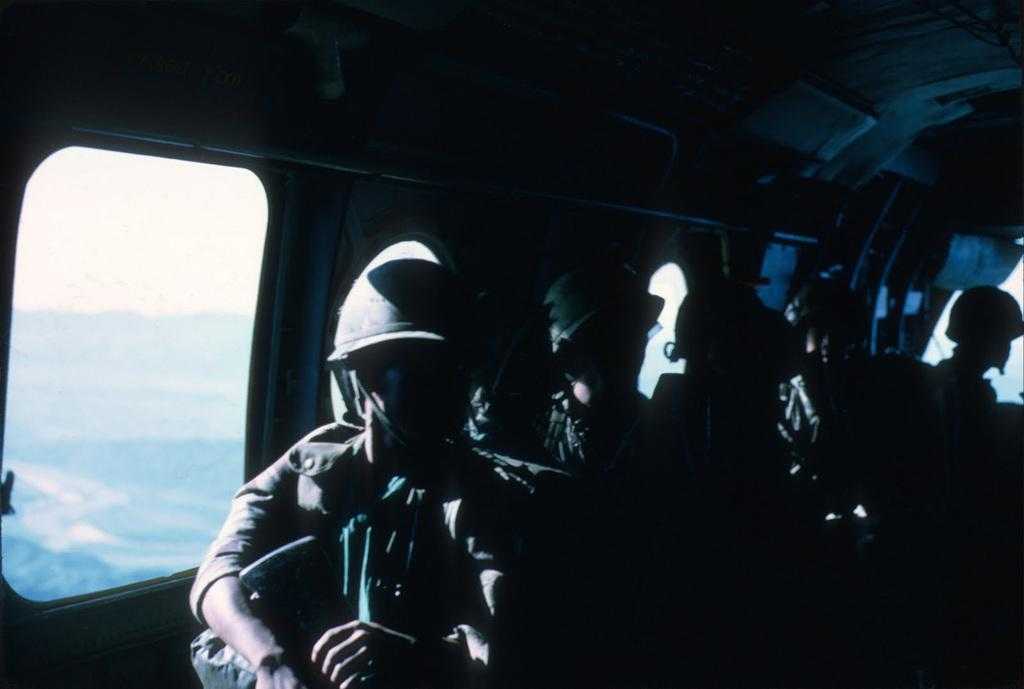What can be seen in the image? There is a group of people in the image. What are the people wearing? The people are wearing dresses and helmets. Where are the people located in the image? The people are sitting inside a vehicle. What is visible in the background of the image? The sky is visible in the background of the image. What type of jam is being spread on the tongue of the person in the image? There is no jam or tongue present in the image; the people are wearing helmets and sitting inside a vehicle. 